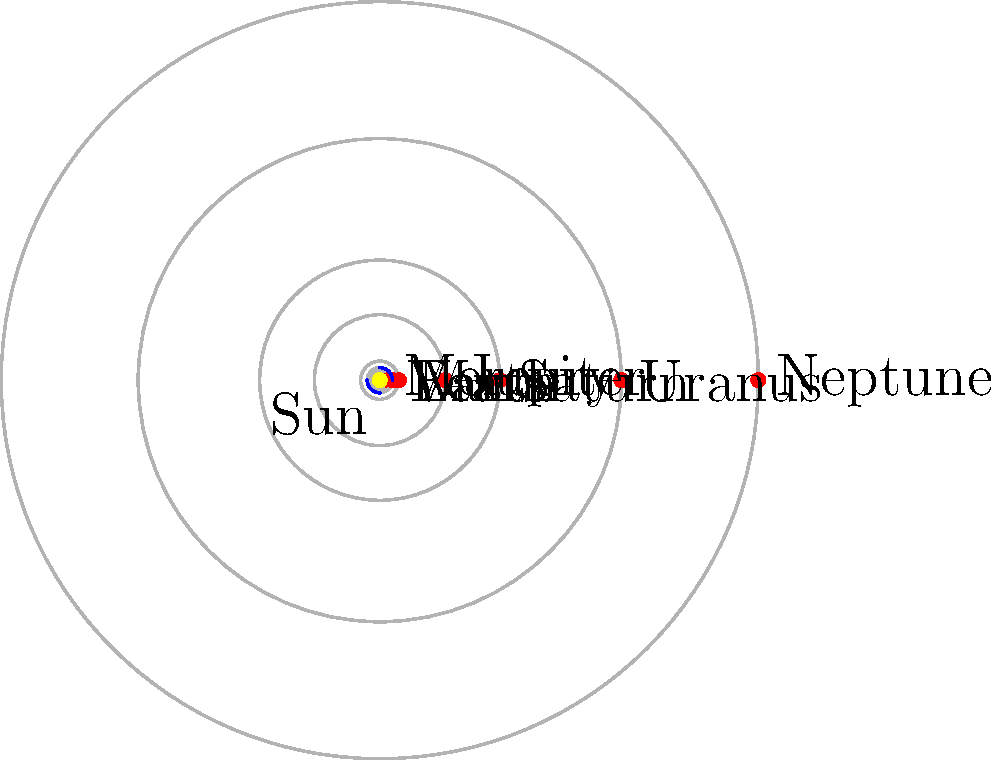In MATLAB, you want to plot the orbits of planets in the solar system as shown in the figure. Given an array `a` containing the semi-major axes of planetary orbits in astronomical units (AU), and an array `planets` containing the names of the planets, which MATLAB function would you use to create circular orbit paths efficiently for all planets in a single line of code? To plot circular orbits efficiently in MATLAB, we can use the `plot` function with complex numbers. Here's a step-by-step explanation:

1. First, we need to create a set of points for each orbit. We can do this using complex numbers on the unit circle and scaling them by the semi-major axis.

2. The unit circle in the complex plane is given by $e^{i\theta}$ where $\theta$ ranges from 0 to $2\pi$.

3. We can generate these points using the `exp` function in MATLAB: `exp(1i * theta)`, where `theta` is a vector of angles.

4. To scale this unit circle to the correct orbit size, we multiply by the semi-major axis: `a(i) * exp(1i * theta)`.

5. To plot all orbits at once, we can use MATLAB's implicit expansion. If `a` is a row vector and `theta` is a column vector, the result will be a matrix where each row represents one orbit.

6. The efficient MATLAB code to generate and plot all orbits would be:
   ```matlab
   theta = linspace(0, 2*pi, 100)';
   plot(a .* exp(1i * theta))
   ```

7. This uses the `plot` function, which can handle complex input directly, plotting the real part on the x-axis and the imaginary part on the y-axis.

8. The `.` before the `*` ensures element-wise multiplication, creating separate orbits for each planet.

Therefore, the most efficient MATLAB function to create circular orbit paths for all planets in a single line of code is `plot`.
Answer: plot 